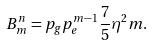Convert formula to latex. <formula><loc_0><loc_0><loc_500><loc_500>B _ { m } ^ { n } = p _ { g } p _ { e } ^ { m - 1 } \frac { 7 } { 5 } \eta ^ { 2 } m .</formula> 